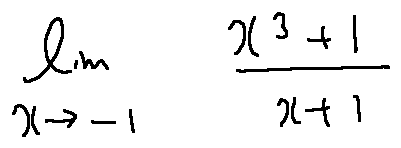<formula> <loc_0><loc_0><loc_500><loc_500>\lim \lim i t s _ { x \rightarrow - 1 } \frac { x ^ { 3 } + 1 } { x + 1 }</formula> 